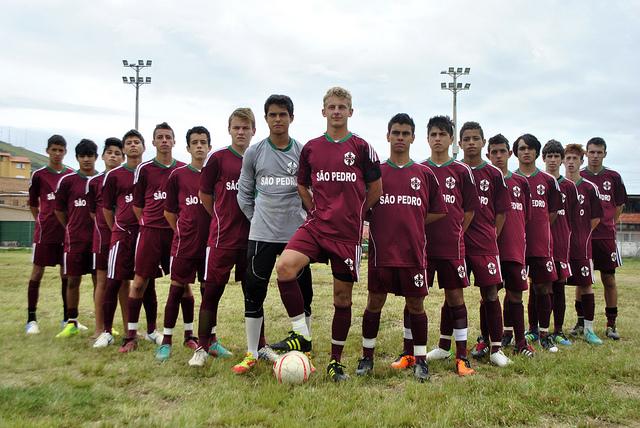How many sneakers have white on them?
Answer briefly. 5. What event is happening?
Write a very short answer. Soccer. What sport do they play?
Short answer required. Soccer. Is there any boys in the picture?
Write a very short answer. Yes. What color is the Jersey for the player with his foot on the ball?
Answer briefly. Red. 